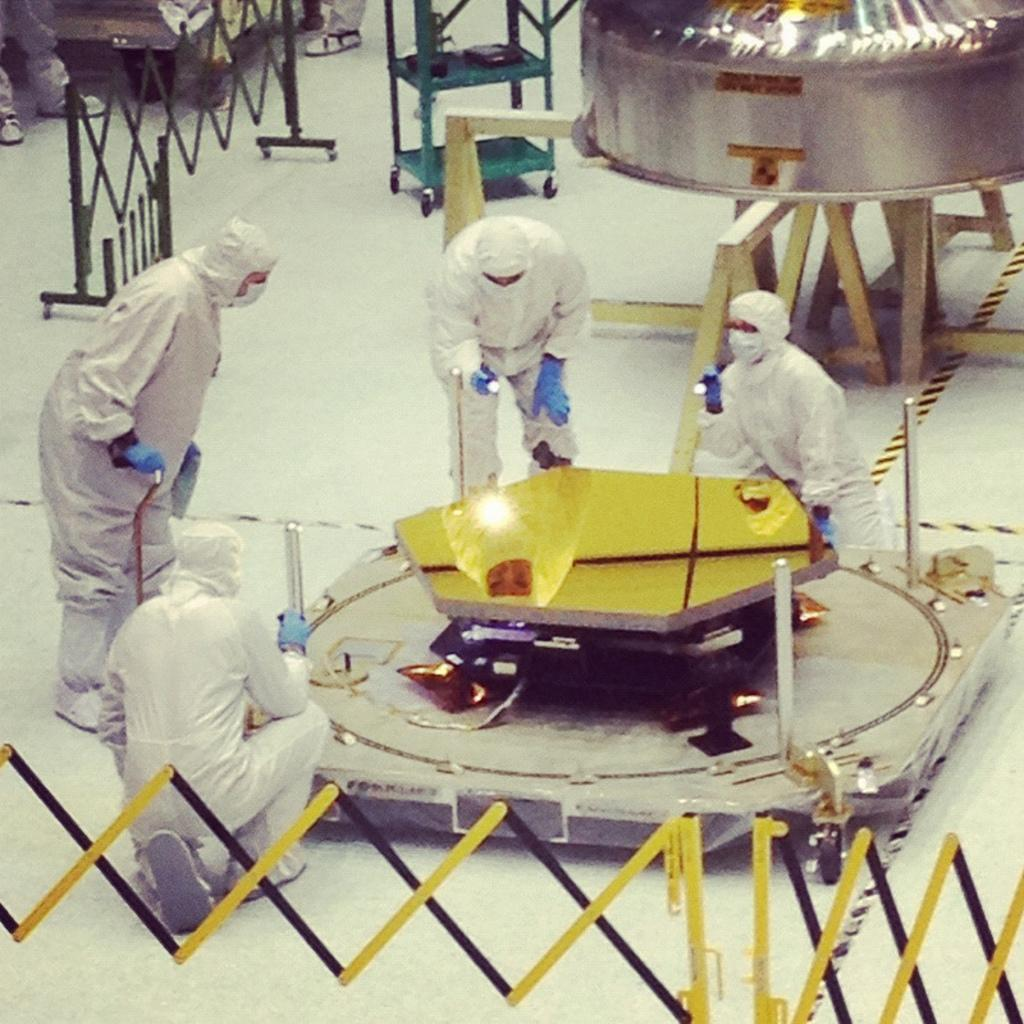Who or what can be seen in the image? There are people in the image. What else is present in the image besides the people? There is an object in the image that looks like a machine, and there are other things on the floor. Can you see a girl wearing a veil in the image? There is no girl wearing a veil present in the image. What is the front of the image showing? The provided facts do not give any information about the front or any specific direction in the image, so it cannot be determined from the given information. 